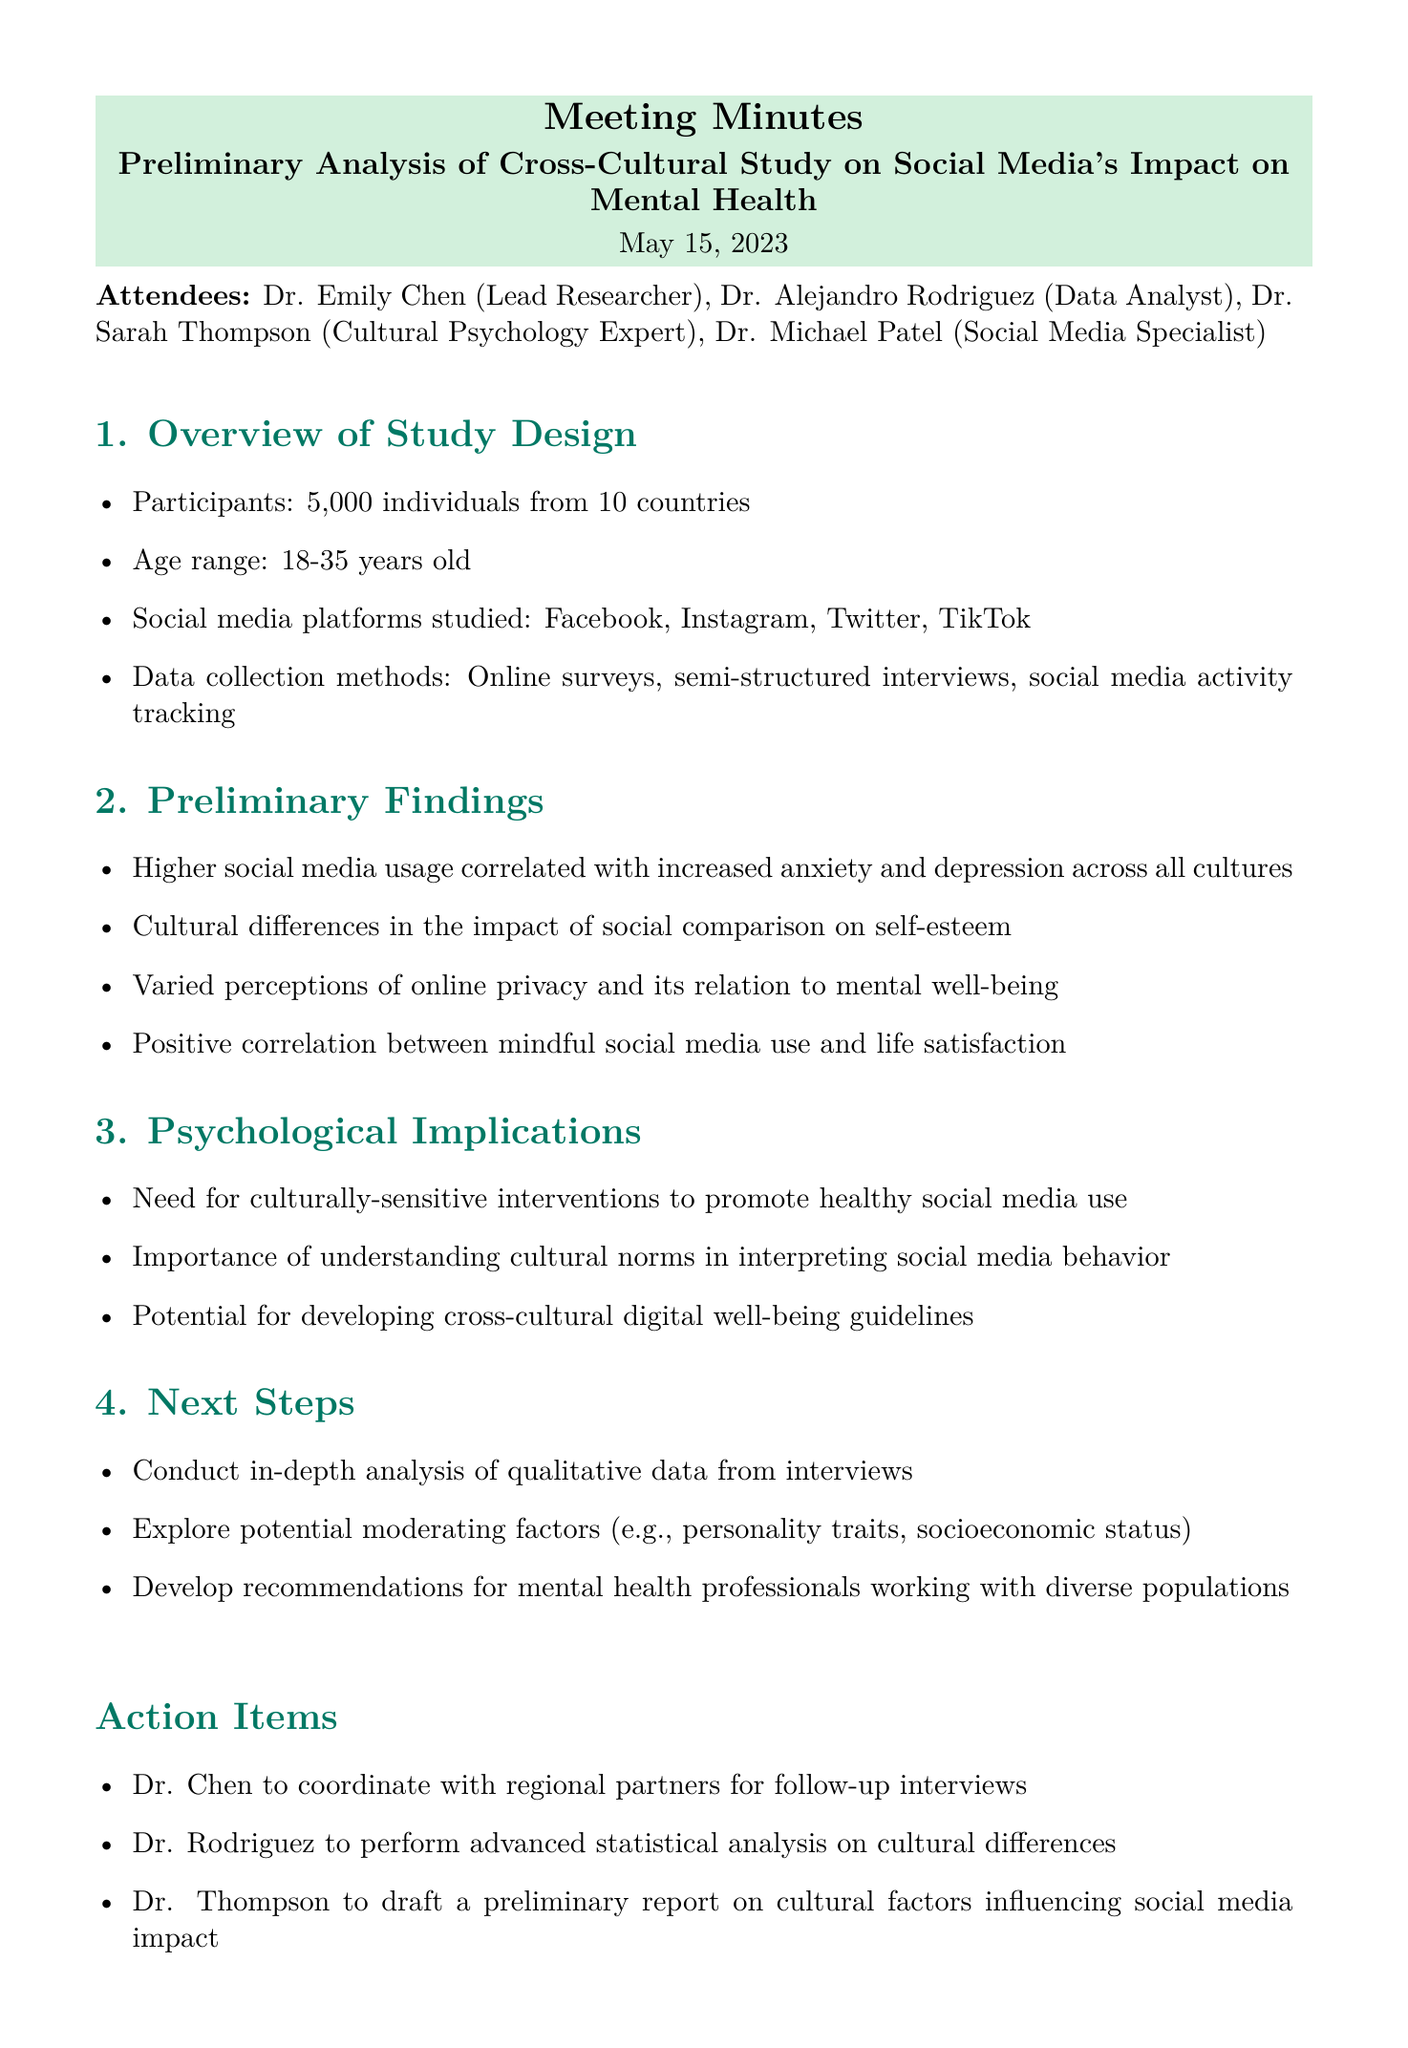What is the meeting title? The meeting title is stated at the beginning of the document, summarizing the main focus of the meeting.
Answer: Preliminary Analysis of Cross-Cultural Study on Social Media's Impact on Mental Health How many participants were involved in the study? The document specifies the number of participants in the overview section of the study design.
Answer: 5,000 Which age range was included in the study? The age range is mentioned as a part of the participant demographic in the overview section.
Answer: 18-35 years old What correlation was found between higher social media usage and mental health? This finding is part of the preliminary findings section and highlights the relationship observed across cultures.
Answer: Increased anxiety and depression What is one of the needs identified in the psychological implications? The document highlights various needs related to the implications of the study, particularly about social media use.
Answer: Culturally-sensitive interventions Who is responsible for conducting follow-up interviews? The action items section specifies responsibilities assigned to different attendees following the meeting.
Answer: Dr. Chen What are the social media platforms studied? The platforms are explicitly listed in the overview of the study design.
Answer: Facebook, Instagram, Twitter, TikTok What is the purpose of the next steps outlined in the meeting? The next steps aim to provide direction for future analysis and intervention development based on findings.
Answer: In-depth analysis of qualitative data from interviews 